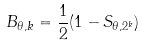Convert formula to latex. <formula><loc_0><loc_0><loc_500><loc_500>B _ { \theta , k } = { \frac { 1 } { 2 } } ( 1 - S _ { \theta , 2 ^ { k } } )</formula> 